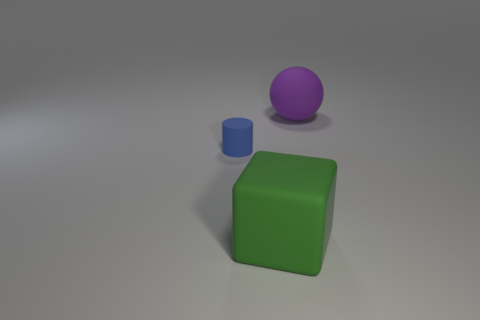Is there anything else that is the same size as the cylinder?
Give a very brief answer. No. Is the number of big green cubes left of the small cylinder greater than the number of small blue rubber cylinders that are behind the big rubber ball?
Your answer should be compact. No. What number of blocks are either tiny things or big rubber things?
Provide a short and direct response. 1. How many big matte blocks are behind the large matte object that is in front of the thing behind the tiny blue rubber object?
Your answer should be compact. 0. Are there more large objects than small brown balls?
Provide a succinct answer. Yes. Is the size of the block the same as the purple rubber thing?
Your answer should be very brief. Yes. What number of objects are blocks or small red spheres?
Provide a succinct answer. 1. What shape is the large thing that is behind the tiny object behind the large thing in front of the tiny rubber object?
Your answer should be compact. Sphere. Is the large green block in front of the blue object made of the same material as the thing that is to the right of the large matte cube?
Keep it short and to the point. Yes. Is the shape of the large thing on the right side of the green object the same as the big rubber thing in front of the tiny cylinder?
Offer a very short reply. No. 